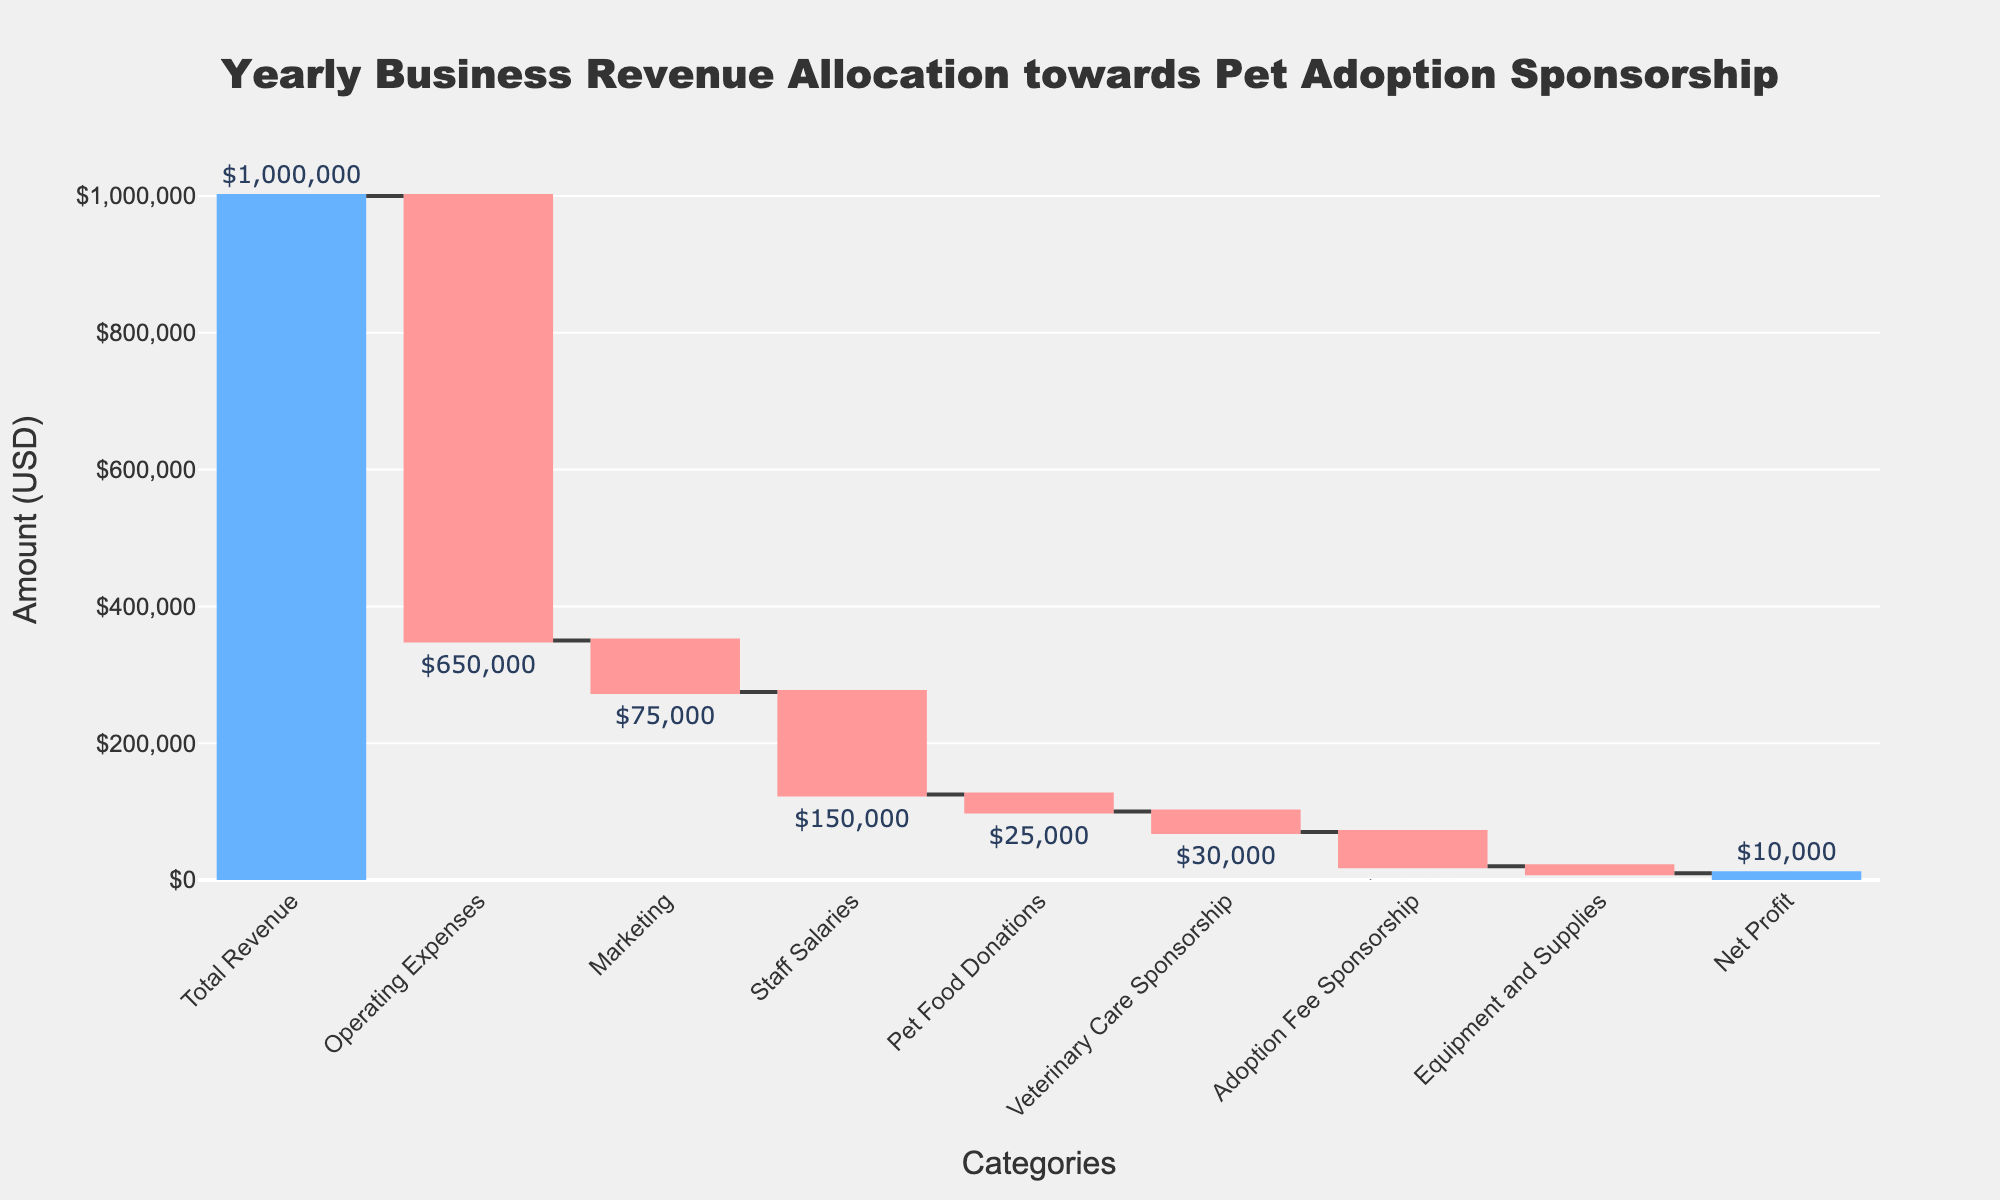What is the title of the chart? The title is usually located at the top of the chart. By reading the title, we get, "Yearly Business Revenue Allocation towards Pet Adoption Sponsorship."
Answer: Yearly Business Revenue Allocation towards Pet Adoption Sponsorship How much is allocated to Operating Expenses? Referring to the category part of the chart, look for the "Operating Expenses" category. By examining it, we see that the value allocated is $650,000.
Answer: $650,000 What is the total revenue for the year? The total revenue is usually the first bar in the waterfall chart. The figure shows a "Total Revenue" with a value of $1,000,000.
Answer: $1,000,000 What is the net profit for the year? To find the net profit, look for the final bar labeled "Net Profit." According to the figure, the Net Profit is $10,000.
Answer: $10,000 How does the allocation for Staff Salaries compare to that for Marketing? In the chart, observe the values for both "Staff Salaries" and "Marketing." Staff Salaries are allocated $150,000, while Marketing is allocated $75,000. Comparing these two values, staff salaries are more.
Answer: Staff Salaries > Marketing What is the combined allocation for Pet Food Donations and Veterinary Care Sponsorship? Identify the values for "Pet Food Donations" and "Veterinary Care Sponsorship." Pet Food Donations are $25,000 and Veterinary Care Sponsorship is $30,000. Sum these figures: $25,000 + $30,000 = $55,000.
Answer: $55,000 What percentage of the total revenue is allocated to Adoption Fee Sponsorship? First, locate the value for "Adoption Fee Sponsorship," which is $50,000. The Total Revenue is $1,000,000. The percentage is calculated as (50,000 / 1,000,000) * 100 = 5%.
Answer: 5% Which category has the smallest allocation, and what is its value? Scan through the values and identify the smallest allocation. "Equipment and Supplies" has the smallest allocation of $10,000.
Answer: Equipment and Supplies, $10,000 How much does the category "Marketing" contribute to the net change in revenue? Observe the value for "Marketing," which is $75,000. Since it is a negative value, it contributes a $75,000 reduction to overall revenue.
Answer: Reduces by $75,000 